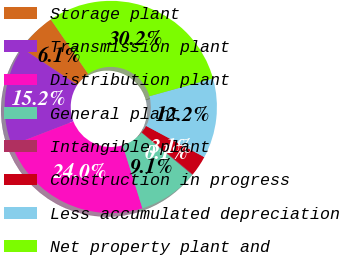<chart> <loc_0><loc_0><loc_500><loc_500><pie_chart><fcel>Storage plant<fcel>Transmission plant<fcel>Distribution plant<fcel>General plant<fcel>Intangible plant<fcel>Construction in progress<fcel>Less accumulated depreciation<fcel>Net property plant and<nl><fcel>6.13%<fcel>15.17%<fcel>23.95%<fcel>9.14%<fcel>0.1%<fcel>3.11%<fcel>12.16%<fcel>30.24%<nl></chart> 